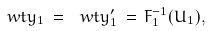Convert formula to latex. <formula><loc_0><loc_0><loc_500><loc_500>\ w t y _ { 1 } \, = \, \ w t y _ { 1 } ^ { \prime } \, = \, F _ { 1 } ^ { - 1 } ( U _ { 1 } ) ,</formula> 